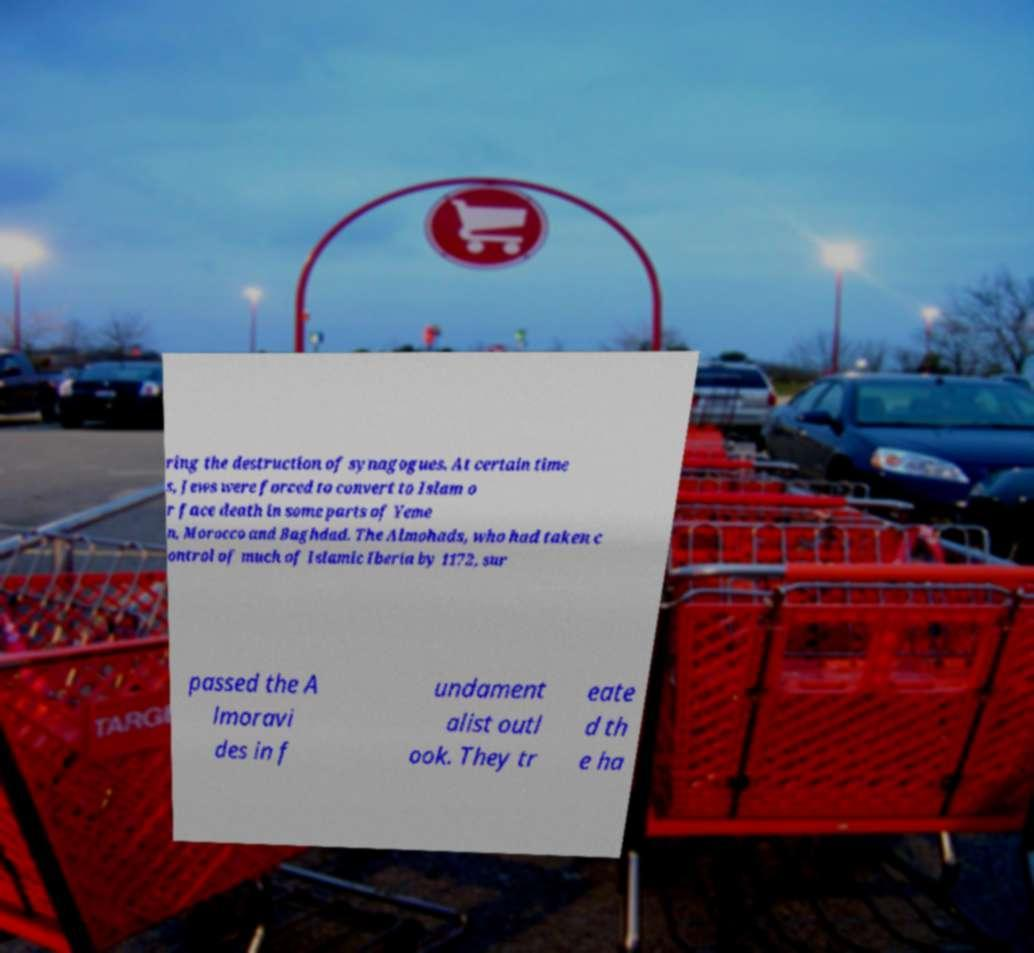Can you read and provide the text displayed in the image?This photo seems to have some interesting text. Can you extract and type it out for me? ring the destruction of synagogues. At certain time s, Jews were forced to convert to Islam o r face death in some parts of Yeme n, Morocco and Baghdad. The Almohads, who had taken c ontrol of much of Islamic Iberia by 1172, sur passed the A lmoravi des in f undament alist outl ook. They tr eate d th e ha 